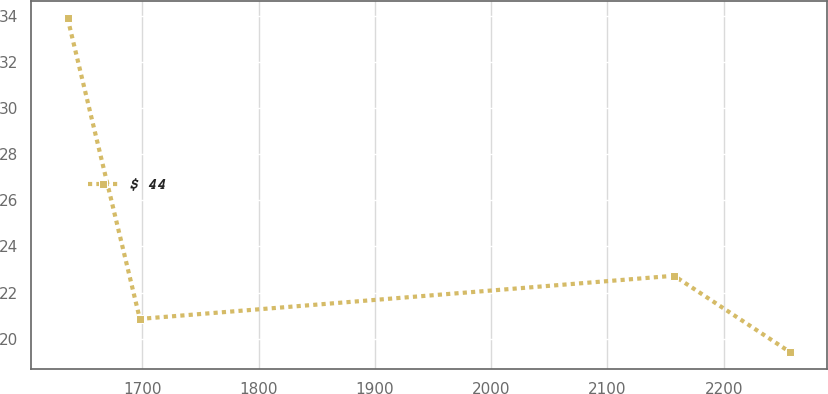<chart> <loc_0><loc_0><loc_500><loc_500><line_chart><ecel><fcel>$ 44<nl><fcel>1635.63<fcel>33.89<nl><fcel>1697.81<fcel>20.86<nl><fcel>2157.25<fcel>22.73<nl><fcel>2257.4<fcel>19.41<nl></chart> 